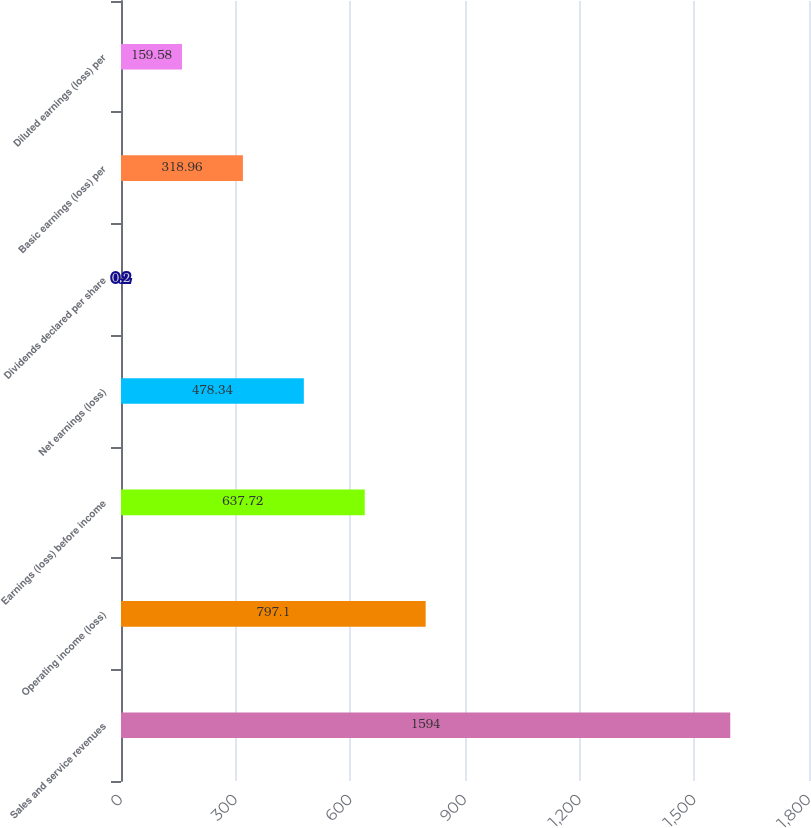Convert chart to OTSL. <chart><loc_0><loc_0><loc_500><loc_500><bar_chart><fcel>Sales and service revenues<fcel>Operating income (loss)<fcel>Earnings (loss) before income<fcel>Net earnings (loss)<fcel>Dividends declared per share<fcel>Basic earnings (loss) per<fcel>Diluted earnings (loss) per<nl><fcel>1594<fcel>797.1<fcel>637.72<fcel>478.34<fcel>0.2<fcel>318.96<fcel>159.58<nl></chart> 